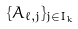Convert formula to latex. <formula><loc_0><loc_0><loc_500><loc_500>\{ A _ { \ell , j } \} _ { j \in I _ { k } }</formula> 